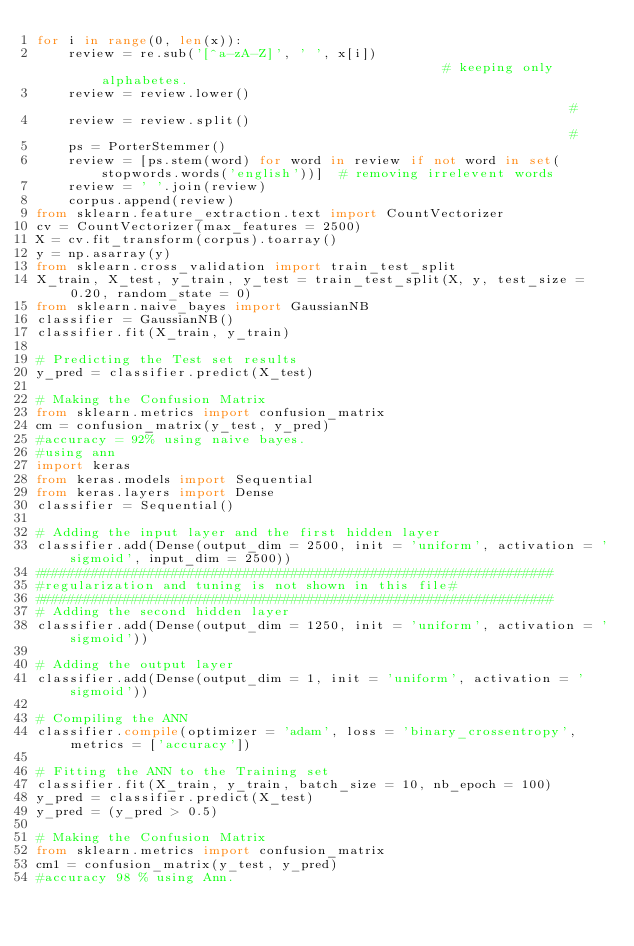Convert code to text. <code><loc_0><loc_0><loc_500><loc_500><_Python_>for i in range(0, len(x)):
    review = re.sub('[^a-zA-Z]', ' ', x[i])                                            # keeping only alphabetes. 
    review = review.lower()                                                            # 
    review = review.split()                                                            # 
    ps = PorterStemmer()
    review = [ps.stem(word) for word in review if not word in set(stopwords.words('english'))]  # removing irrelevent words  
    review = ' '.join(review)
    corpus.append(review)
from sklearn.feature_extraction.text import CountVectorizer
cv = CountVectorizer(max_features = 2500)
X = cv.fit_transform(corpus).toarray()
y = np.asarray(y)
from sklearn.cross_validation import train_test_split
X_train, X_test, y_train, y_test = train_test_split(X, y, test_size = 0.20, random_state = 0)
from sklearn.naive_bayes import GaussianNB
classifier = GaussianNB()
classifier.fit(X_train, y_train)

# Predicting the Test set results
y_pred = classifier.predict(X_test)

# Making the Confusion Matrix
from sklearn.metrics import confusion_matrix
cm = confusion_matrix(y_test, y_pred)
#accuracy = 92% using naive bayes.
#using ann
import keras
from keras.models import Sequential
from keras.layers import Dense
classifier = Sequential()

# Adding the input layer and the first hidden layer
classifier.add(Dense(output_dim = 2500, init = 'uniform', activation = 'sigmoid', input_dim = 2500))
#################################################################
#regularization and tuning is not shown in this file#
#################################################################
# Adding the second hidden layer
classifier.add(Dense(output_dim = 1250, init = 'uniform', activation = 'sigmoid'))

# Adding the output layer
classifier.add(Dense(output_dim = 1, init = 'uniform', activation = 'sigmoid'))

# Compiling the ANN
classifier.compile(optimizer = 'adam', loss = 'binary_crossentropy', metrics = ['accuracy'])

# Fitting the ANN to the Training set
classifier.fit(X_train, y_train, batch_size = 10, nb_epoch = 100)
y_pred = classifier.predict(X_test)
y_pred = (y_pred > 0.5)

# Making the Confusion Matrix
from sklearn.metrics import confusion_matrix
cm1 = confusion_matrix(y_test, y_pred)
#accuracy 98 % using Ann.
</code> 